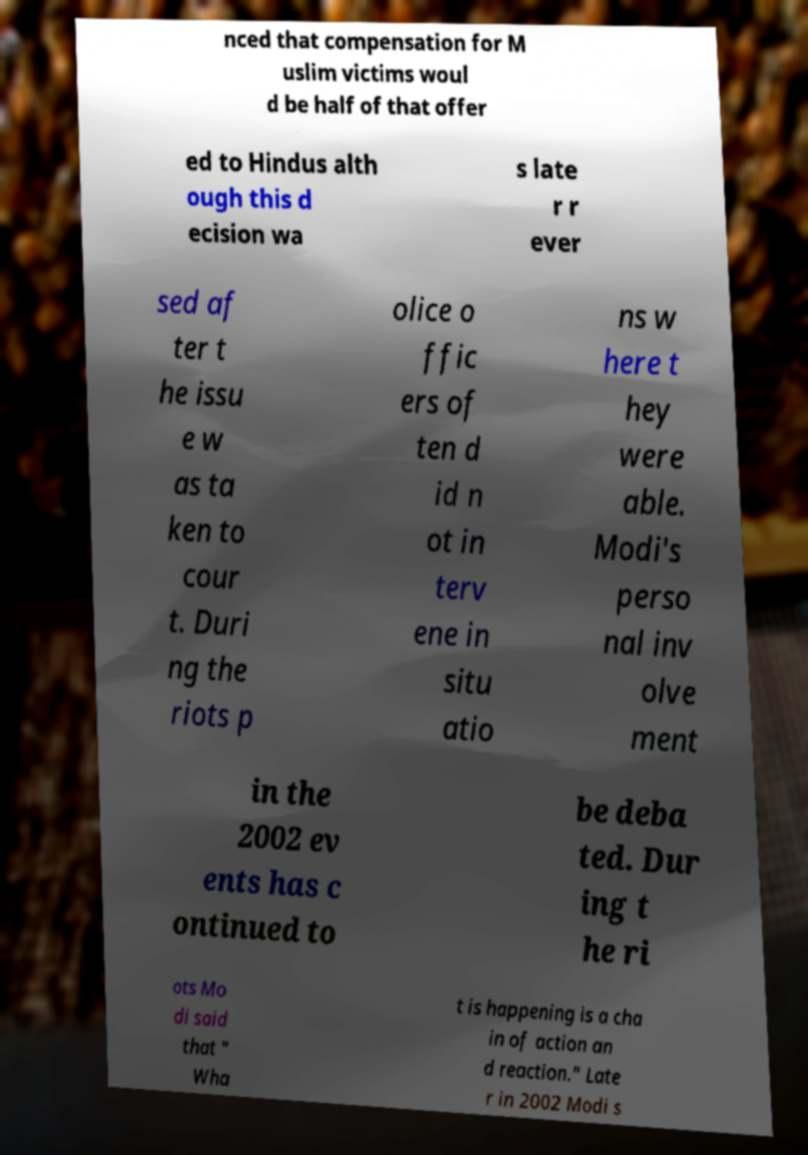Can you read and provide the text displayed in the image?This photo seems to have some interesting text. Can you extract and type it out for me? nced that compensation for M uslim victims woul d be half of that offer ed to Hindus alth ough this d ecision wa s late r r ever sed af ter t he issu e w as ta ken to cour t. Duri ng the riots p olice o ffic ers of ten d id n ot in terv ene in situ atio ns w here t hey were able. Modi's perso nal inv olve ment in the 2002 ev ents has c ontinued to be deba ted. Dur ing t he ri ots Mo di said that " Wha t is happening is a cha in of action an d reaction." Late r in 2002 Modi s 